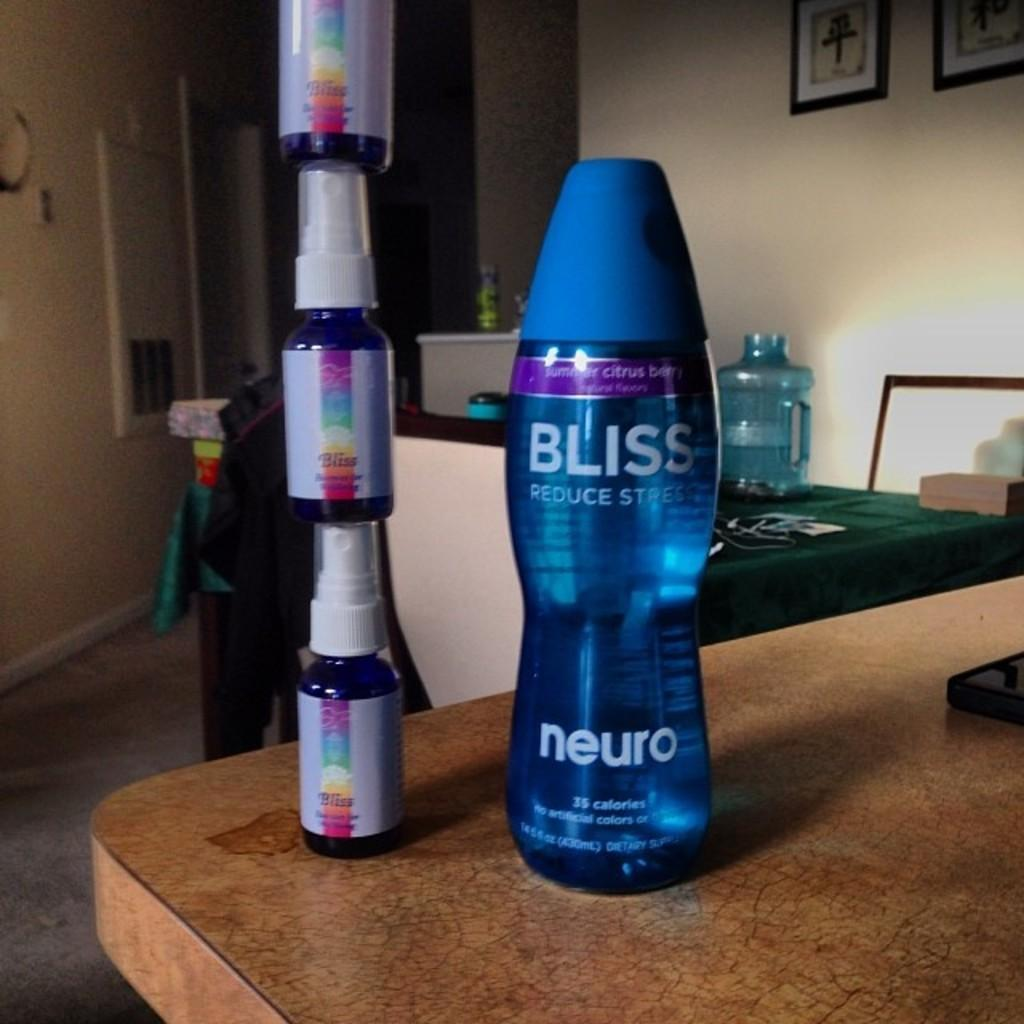<image>
Relay a brief, clear account of the picture shown. A blue Bliss brand drink is on the table next to rainbow colored Bliss drinks that are stacked on top of each other. 